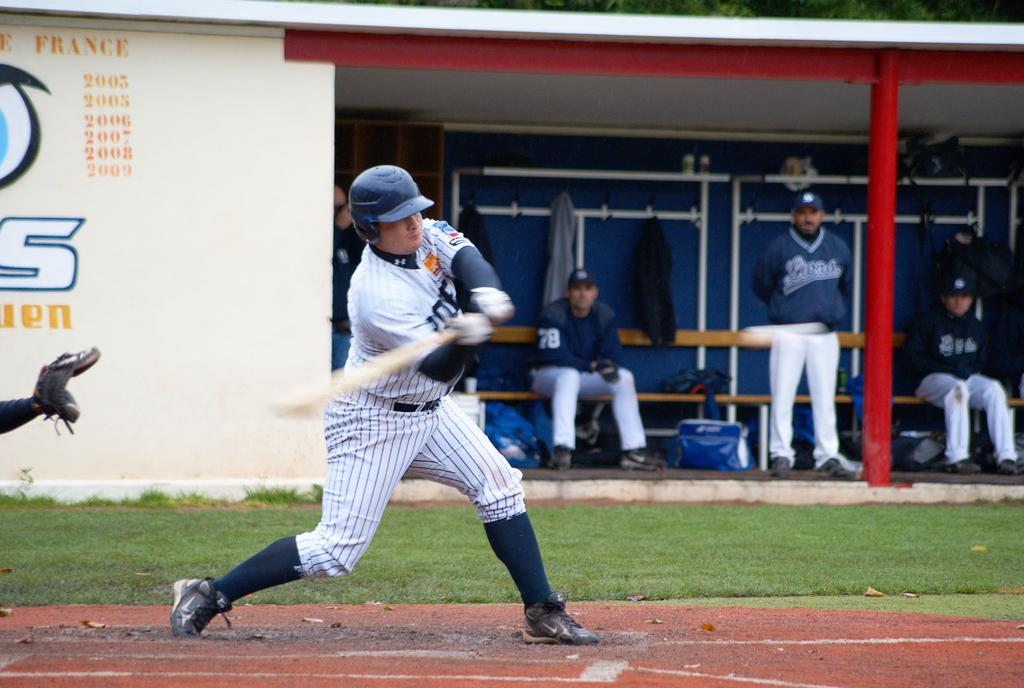<image>
Write a terse but informative summary of the picture. A baseball player is swinging at a pitch by a wall that says France. 